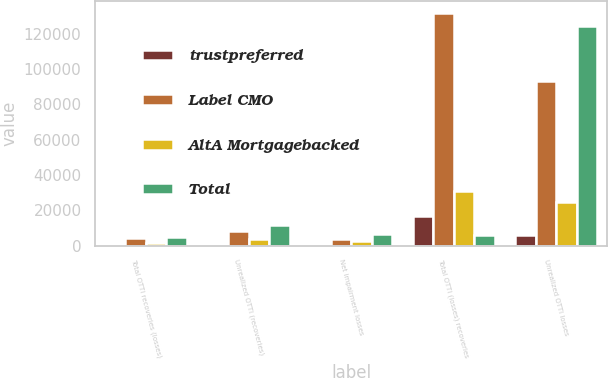Convert chart to OTSL. <chart><loc_0><loc_0><loc_500><loc_500><stacked_bar_chart><ecel><fcel>Total OTTI recoveries (losses)<fcel>Unrealized OTTI (recoveries)<fcel>Net impairment losses<fcel>Total OTTI (losses) recoveries<fcel>Unrealized OTTI losses<nl><fcel>trustpreferred<fcel>724<fcel>363<fcel>361<fcel>16906<fcel>6186<nl><fcel>Label CMO<fcel>4389<fcel>8187<fcel>3798<fcel>131902<fcel>93491<nl><fcel>AltA Mortgagebacked<fcel>1163<fcel>3713<fcel>2550<fcel>30727<fcel>24731<nl><fcel>Total<fcel>4828<fcel>11537<fcel>6709<fcel>6186<fcel>124408<nl></chart> 